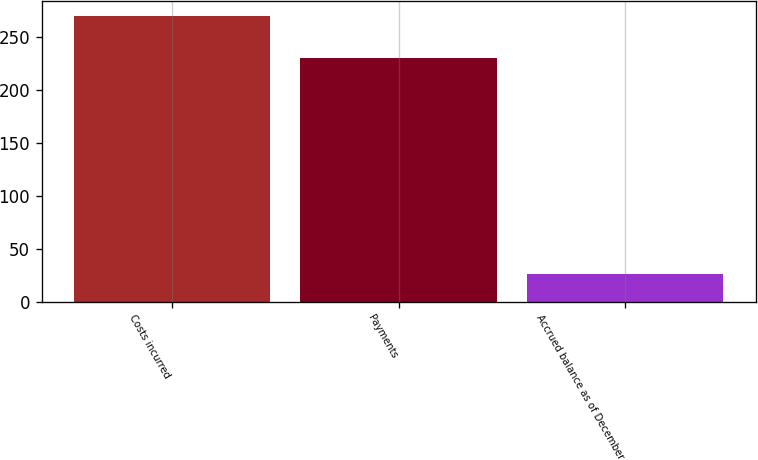<chart> <loc_0><loc_0><loc_500><loc_500><bar_chart><fcel>Costs incurred<fcel>Payments<fcel>Accrued balance as of December<nl><fcel>270<fcel>230<fcel>26<nl></chart> 